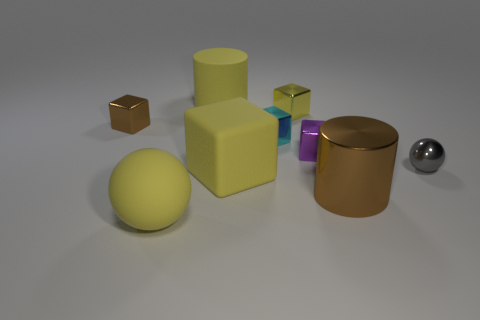Do the brown metal object in front of the brown block and the small object to the right of the shiny cylinder have the same shape?
Provide a succinct answer. No. What material is the small brown thing?
Your answer should be very brief. Metal. There is a small thing that is the same color as the large rubber cylinder; what is its shape?
Offer a very short reply. Cube. What number of metal cylinders are the same size as the shiny ball?
Provide a succinct answer. 0. How many things are either tiny metal things that are to the right of the large matte cylinder or tiny cubes behind the small brown metal object?
Provide a succinct answer. 4. Is the material of the brown object that is to the left of the yellow rubber cylinder the same as the brown object right of the big sphere?
Your answer should be compact. Yes. There is a matte thing that is behind the tiny yellow metal object that is behind the rubber ball; what shape is it?
Offer a terse response. Cylinder. Are there any other things of the same color as the matte block?
Offer a terse response. Yes. There is a brown metallic thing in front of the block left of the large yellow matte ball; is there a brown cylinder on the left side of it?
Ensure brevity in your answer.  No. Is the color of the cylinder behind the big metal cylinder the same as the matte object that is in front of the brown cylinder?
Keep it short and to the point. Yes. 